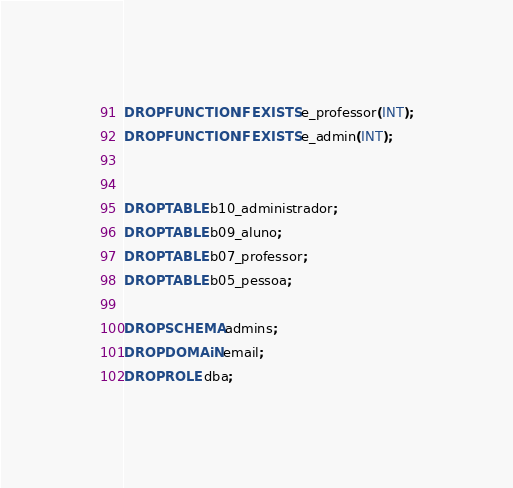<code> <loc_0><loc_0><loc_500><loc_500><_SQL_>DROP FUNCTION IF EXISTS e_professor(INT);
DROP FUNCTION IF EXISTS e_admin(INT);


DROP TABLE b10_administrador;
DROP TABLE b09_aluno;
DROP TABLE b07_professor;
DROP TABLE b05_pessoa;

DROP SCHEMA admins;
DROP DOMAiN email;
DROP ROLE dba;
</code> 